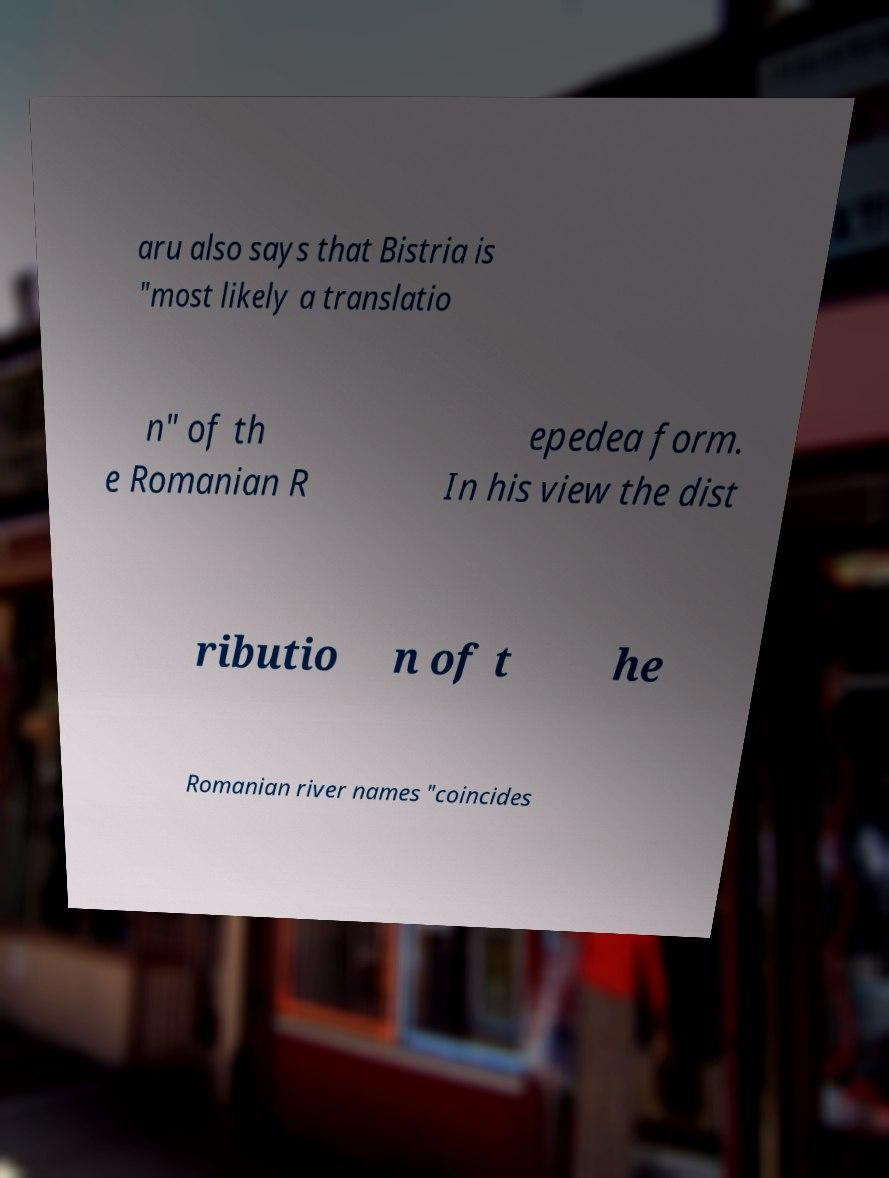Please identify and transcribe the text found in this image. aru also says that Bistria is "most likely a translatio n" of th e Romanian R epedea form. In his view the dist ributio n of t he Romanian river names "coincides 